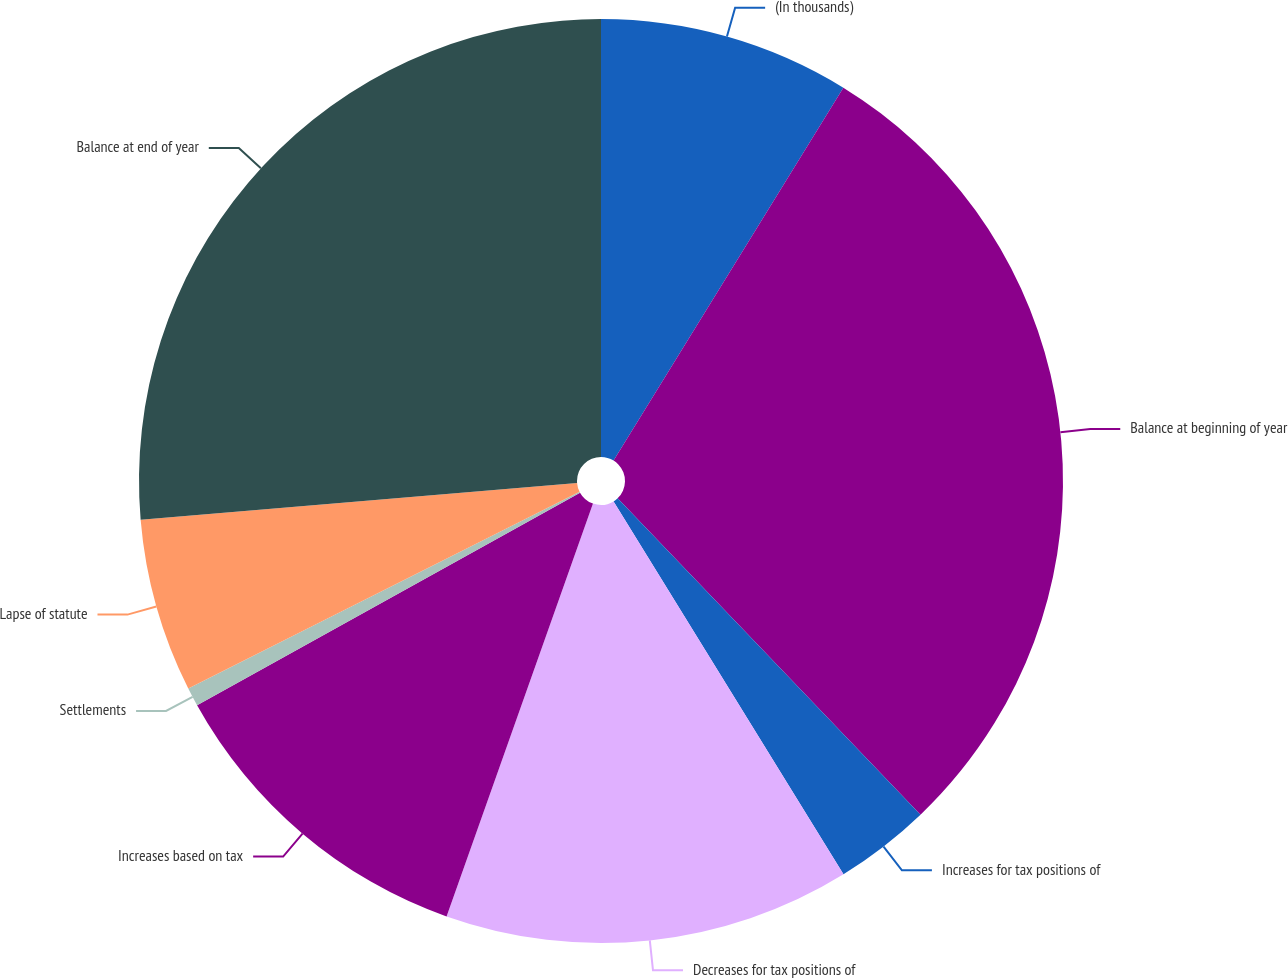Convert chart. <chart><loc_0><loc_0><loc_500><loc_500><pie_chart><fcel>(In thousands)<fcel>Balance at beginning of year<fcel>Increases for tax positions of<fcel>Decreases for tax positions of<fcel>Increases based on tax<fcel>Settlements<fcel>Lapse of statute<fcel>Balance at end of year<nl><fcel>8.79%<fcel>29.06%<fcel>3.36%<fcel>14.22%<fcel>11.51%<fcel>0.65%<fcel>6.08%<fcel>26.34%<nl></chart> 